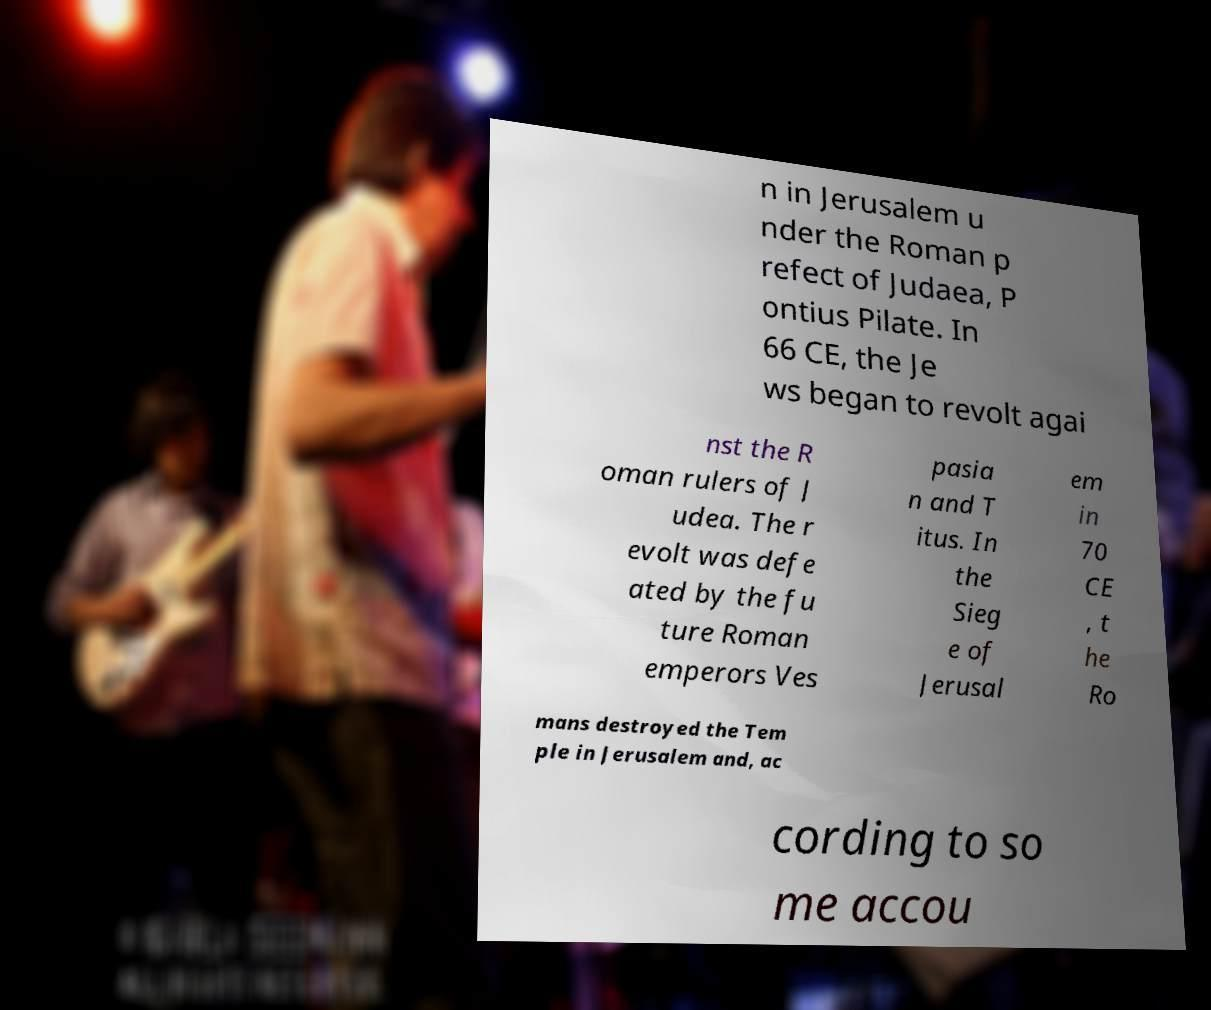Could you assist in decoding the text presented in this image and type it out clearly? n in Jerusalem u nder the Roman p refect of Judaea, P ontius Pilate. In 66 CE, the Je ws began to revolt agai nst the R oman rulers of J udea. The r evolt was defe ated by the fu ture Roman emperors Ves pasia n and T itus. In the Sieg e of Jerusal em in 70 CE , t he Ro mans destroyed the Tem ple in Jerusalem and, ac cording to so me accou 